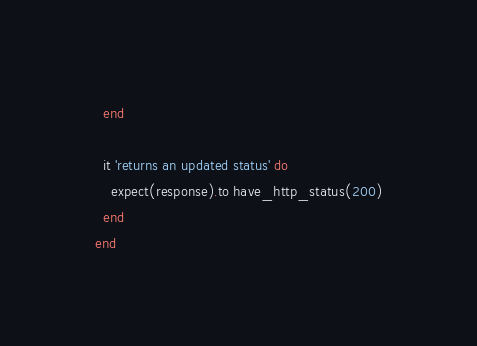Convert code to text. <code><loc_0><loc_0><loc_500><loc_500><_Ruby_>  end

  it 'returns an updated status' do
    expect(response).to have_http_status(200)
  end
end</code> 